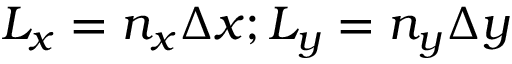<formula> <loc_0><loc_0><loc_500><loc_500>L _ { x } = n _ { x } \Delta x ; L _ { y } = n _ { y } \Delta y</formula> 